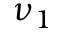Convert formula to latex. <formula><loc_0><loc_0><loc_500><loc_500>\nu _ { 1 }</formula> 